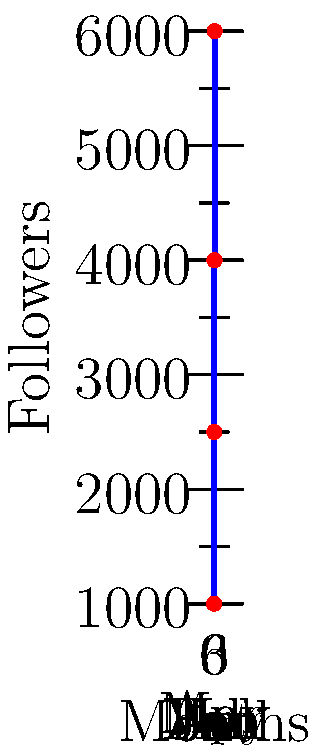The step chart shows the growth of social media followers for your veteran-owned clothing brand over a 7-month period. During which month did the brand experience the largest percentage increase in followers? To determine the month with the largest percentage increase in followers, we need to calculate the percentage change for each step in the chart:

1. January to February: No change (0% increase)
2. February to March: 
   $\frac{2500 - 1000}{1000} \times 100\% = 150\%$ increase
3. March to April: No change (0% increase)
4. April to May:
   $\frac{4000 - 2500}{2500} \times 100\% = 60\%$ increase
5. May to June: No change (0% increase)
6. June to July:
   $\frac{6000 - 4000}{4000} \times 100\% = 50\%$ increase

The largest percentage increase occurred from February to March, with a 150% increase in followers.
Answer: March 